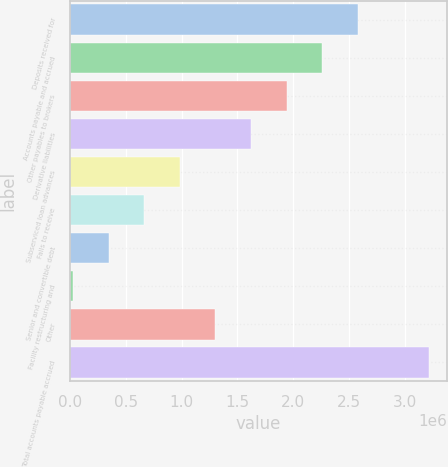<chart> <loc_0><loc_0><loc_500><loc_500><bar_chart><fcel>Deposits received for<fcel>Accounts payable and accrued<fcel>Other payables to brokers<fcel>Derivative liabilities<fcel>Subserviced loan advances<fcel>Fails to receive<fcel>Senior and convertible debt<fcel>Facility restructuring and<fcel>Other<fcel>Total accounts payable accrued<nl><fcel>2.57777e+06<fcel>2.25888e+06<fcel>1.93999e+06<fcel>1.6211e+06<fcel>983320<fcel>664430<fcel>345541<fcel>26651<fcel>1.30221e+06<fcel>3.21555e+06<nl></chart> 